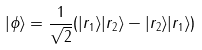<formula> <loc_0><loc_0><loc_500><loc_500>| \phi \rangle = \frac { 1 } { \sqrt { 2 } } ( | r _ { 1 } \rangle | r _ { 2 } \rangle - | r _ { 2 } \rangle | r _ { 1 } \rangle )</formula> 